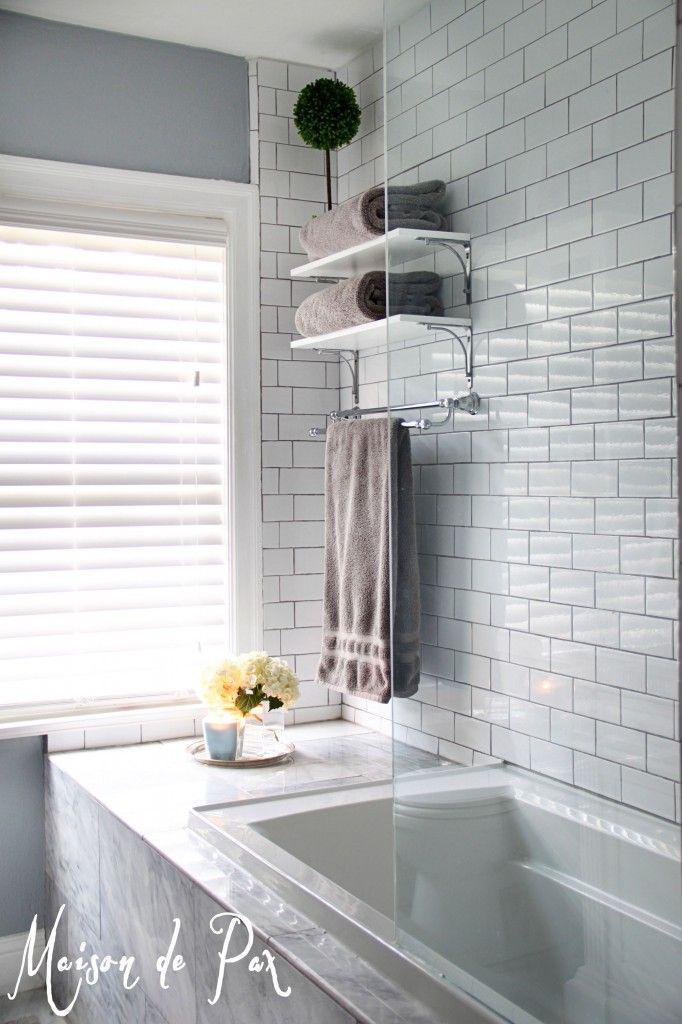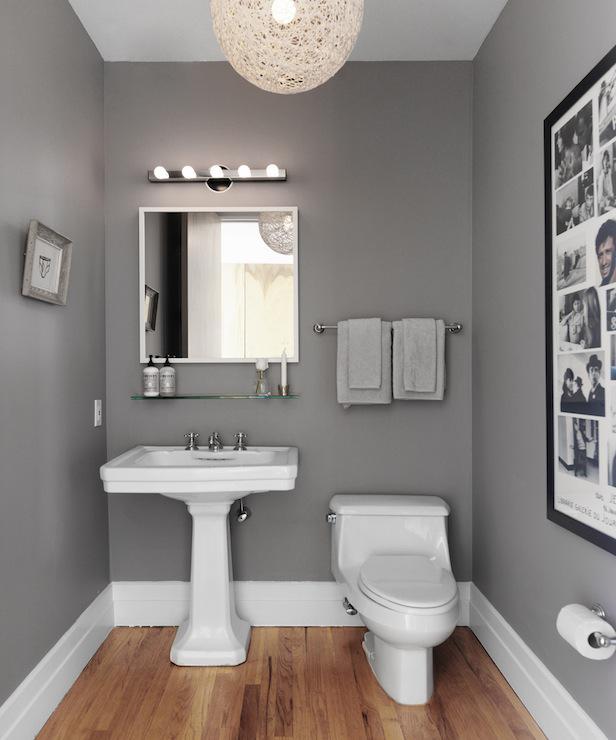The first image is the image on the left, the second image is the image on the right. Considering the images on both sides, is "A toilet is visible in the right image." valid? Answer yes or no. Yes. The first image is the image on the left, the second image is the image on the right. For the images displayed, is the sentence "There are objects sitting on bath towels." factually correct? Answer yes or no. No. 